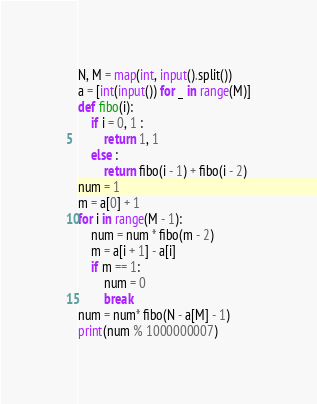<code> <loc_0><loc_0><loc_500><loc_500><_Python_>N, M = map(int, input().split())
a = [int(input()) for _ in range(M)]
def fibo(i):
    if i = 0, 1 :
        return 1, 1
    else :
        return fibo(i - 1) + fibo(i - 2)
num = 1
m = a[0] + 1
for i in range(M - 1):
    num = num * fibo(m - 2)
    m = a[i + 1] - a[i]
    if m == 1:
        num = 0
        break
num = num* fibo(N - a[M] - 1)
print(num % 1000000007)
</code> 